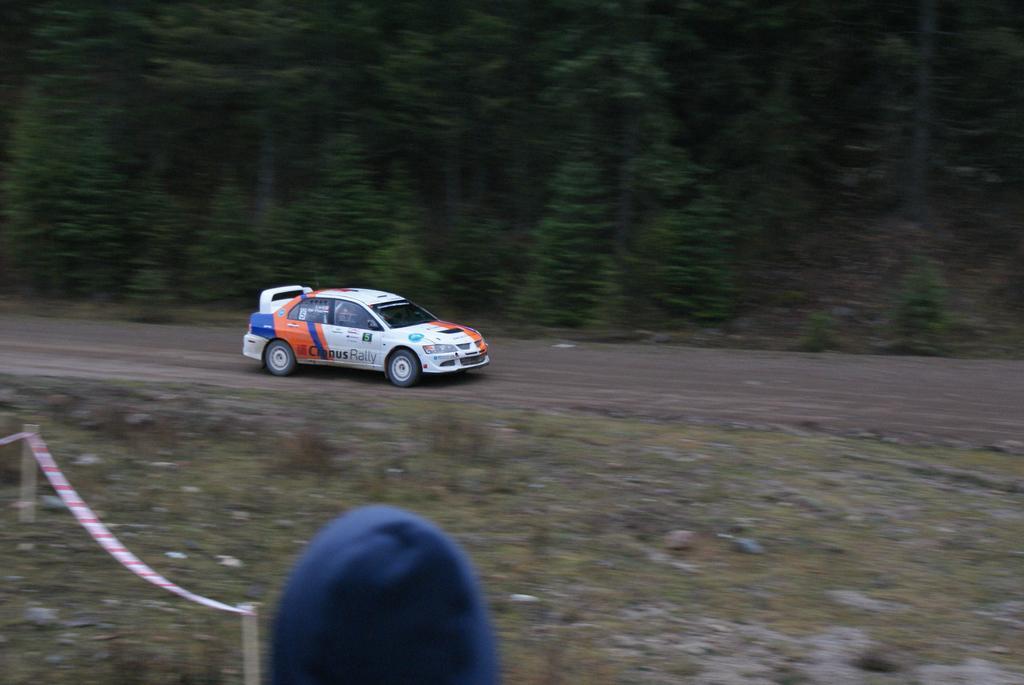Can you describe this image briefly? In this image at the bottom we can see a cap, caution tape tied to the small poles. In the background we can see a person is riding car on the road and we can see plants, trees, stones and trees on the ground. 